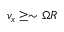<formula> <loc_0><loc_0><loc_500><loc_500>v _ { x } \geq \sim \Omega R</formula> 